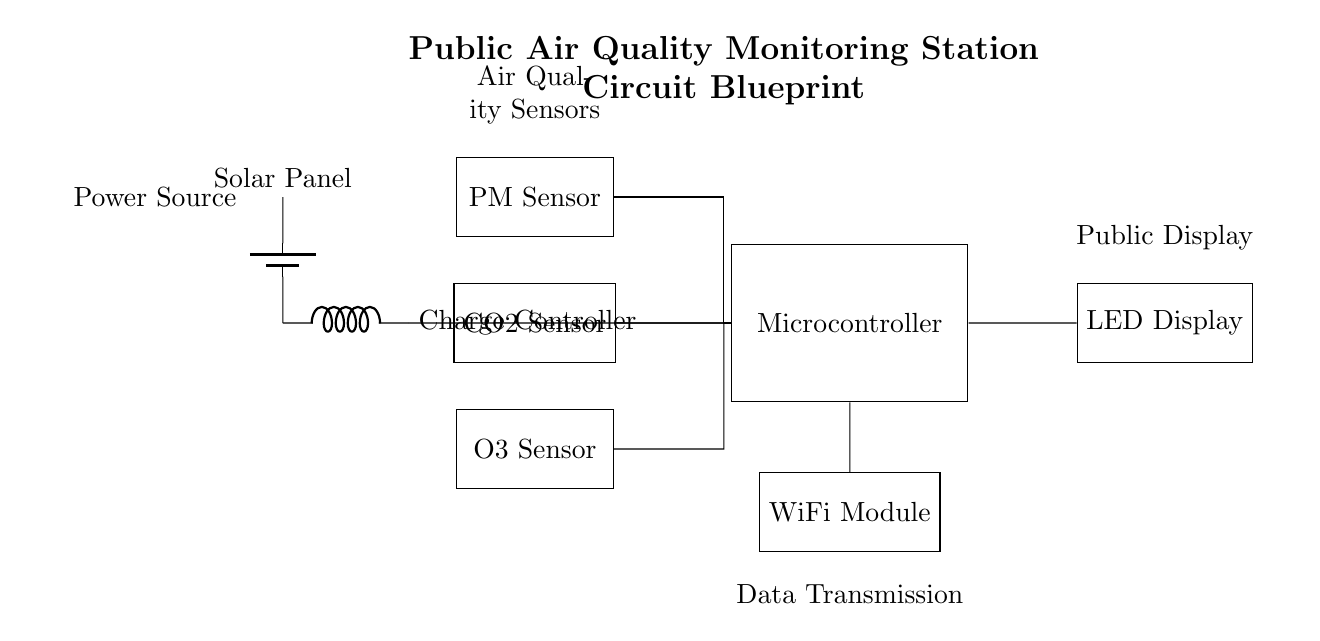What are the types of sensors used in this circuit? The circuit has three distinct sensors labeled as PM Sensor, CO2 Sensor, and O3 Sensor, which can be identified as components in the diagram.
Answer: PM Sensor, CO2 Sensor, O3 Sensor What is the role of the microcontroller? The microcontroller processes data received from the sensors and facilitates the display and transmission of this data to the LED display and WiFi module, as indicated by the connections made to these components.
Answer: Data processing What powers the circuit? The power source consists of a solar panel and a charge controller, which can be observed in the circuit; the battery provides the necessary energy for operation.
Answer: Solar panel How many components are directly connected to the microcontroller? The microcontroller is connected to four components: the PM Sensor, CO2 Sensor, O3 Sensor, and the power supply, which can be counted from the lines connecting these elements to the microcontroller in the diagram.
Answer: Four What is displayed on the LED display? The LED display shows real-time data from the air quality sensors as indicated by its connection to the microcontroller; thus, its purpose is to present this processed data visually.
Answer: Real-time data What module is used for data transmission in the circuit? The circuit employs a WiFi module for data transmission, which can be identified from its labeled representation and connection to the microcontroller.
Answer: WiFi module What is the function of the charge controller? The charge controller regulates the power coming from the solar panel, ensuring that the microcontroller receives stable and safe voltage, as indicated by its connection in the power section of the circuit.
Answer: Power regulation 